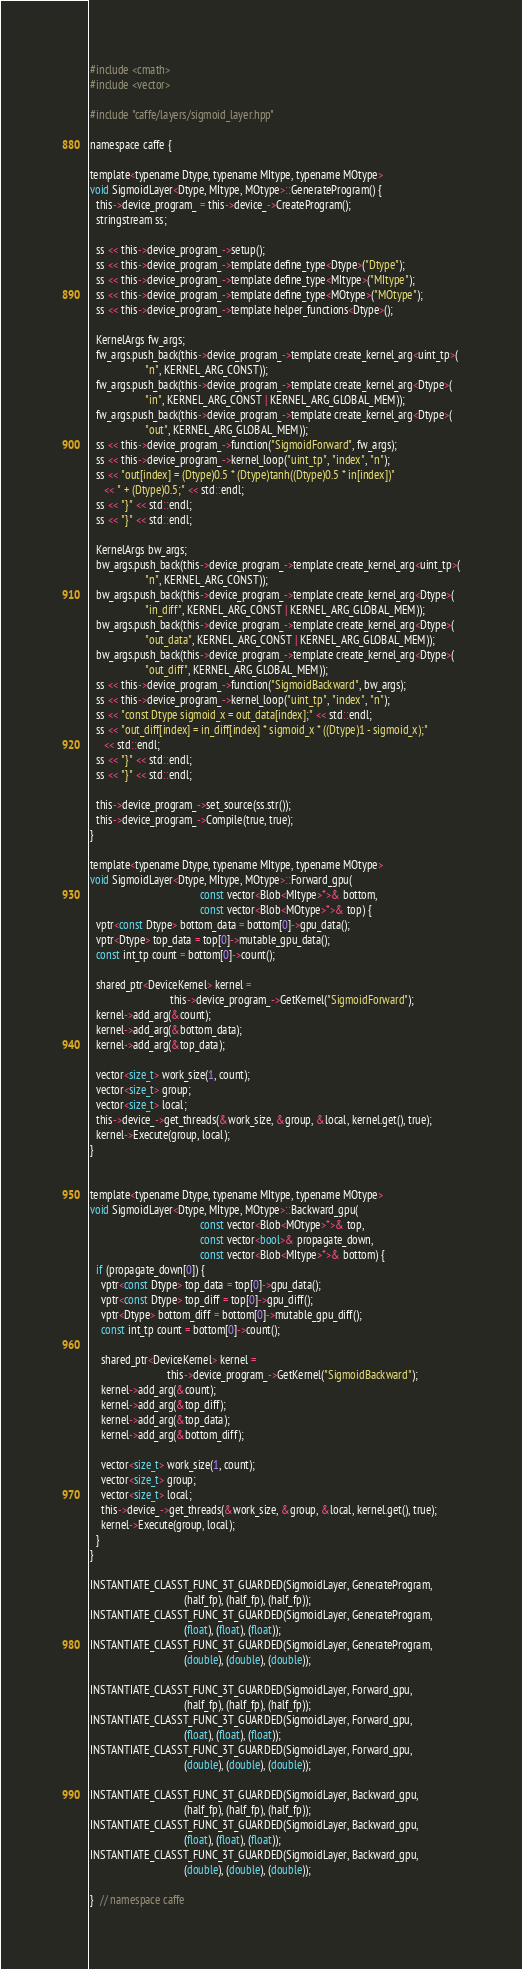<code> <loc_0><loc_0><loc_500><loc_500><_Cuda_>#include <cmath>
#include <vector>

#include "caffe/layers/sigmoid_layer.hpp"

namespace caffe {

template<typename Dtype, typename MItype, typename MOtype>
void SigmoidLayer<Dtype, MItype, MOtype>::GenerateProgram() {
  this->device_program_ = this->device_->CreateProgram();
  stringstream ss;

  ss << this->device_program_->setup();
  ss << this->device_program_->template define_type<Dtype>("Dtype");
  ss << this->device_program_->template define_type<MItype>("MItype");
  ss << this->device_program_->template define_type<MOtype>("MOtype");
  ss << this->device_program_->template helper_functions<Dtype>();

  KernelArgs fw_args;
  fw_args.push_back(this->device_program_->template create_kernel_arg<uint_tp>(
                    "n", KERNEL_ARG_CONST));
  fw_args.push_back(this->device_program_->template create_kernel_arg<Dtype>(
                    "in", KERNEL_ARG_CONST | KERNEL_ARG_GLOBAL_MEM));
  fw_args.push_back(this->device_program_->template create_kernel_arg<Dtype>(
                    "out", KERNEL_ARG_GLOBAL_MEM));
  ss << this->device_program_->function("SigmoidForward", fw_args);
  ss << this->device_program_->kernel_loop("uint_tp", "index", "n");
  ss << "out[index] = (Dtype)0.5 * (Dtype)tanh((Dtype)0.5 * in[index])"
     << " + (Dtype)0.5;" << std::endl;
  ss << "}" << std::endl;
  ss << "}" << std::endl;

  KernelArgs bw_args;
  bw_args.push_back(this->device_program_->template create_kernel_arg<uint_tp>(
                    "n", KERNEL_ARG_CONST));
  bw_args.push_back(this->device_program_->template create_kernel_arg<Dtype>(
                    "in_diff", KERNEL_ARG_CONST | KERNEL_ARG_GLOBAL_MEM));
  bw_args.push_back(this->device_program_->template create_kernel_arg<Dtype>(
                    "out_data", KERNEL_ARG_CONST | KERNEL_ARG_GLOBAL_MEM));
  bw_args.push_back(this->device_program_->template create_kernel_arg<Dtype>(
                    "out_diff", KERNEL_ARG_GLOBAL_MEM));
  ss << this->device_program_->function("SigmoidBackward", bw_args);
  ss << this->device_program_->kernel_loop("uint_tp", "index", "n");
  ss << "const Dtype sigmoid_x = out_data[index];" << std::endl;
  ss << "out_diff[index] = in_diff[index] * sigmoid_x * ((Dtype)1 - sigmoid_x);"
     << std::endl;
  ss << "}" << std::endl;
  ss << "}" << std::endl;

  this->device_program_->set_source(ss.str());
  this->device_program_->Compile(true, true);
}

template<typename Dtype, typename MItype, typename MOtype>
void SigmoidLayer<Dtype, MItype, MOtype>::Forward_gpu(
                                        const vector<Blob<MItype>*>& bottom,
                                        const vector<Blob<MOtype>*>& top) {
  vptr<const Dtype> bottom_data = bottom[0]->gpu_data();
  vptr<Dtype> top_data = top[0]->mutable_gpu_data();
  const int_tp count = bottom[0]->count();

  shared_ptr<DeviceKernel> kernel =
                             this->device_program_->GetKernel("SigmoidForward");
  kernel->add_arg(&count);
  kernel->add_arg(&bottom_data);
  kernel->add_arg(&top_data);

  vector<size_t> work_size(1, count);
  vector<size_t> group;
  vector<size_t> local;
  this->device_->get_threads(&work_size, &group, &local, kernel.get(), true);
  kernel->Execute(group, local);
}


template<typename Dtype, typename MItype, typename MOtype>
void SigmoidLayer<Dtype, MItype, MOtype>::Backward_gpu(
                                        const vector<Blob<MOtype>*>& top,
                                        const vector<bool>& propagate_down,
                                        const vector<Blob<MItype>*>& bottom) {
  if (propagate_down[0]) {
    vptr<const Dtype> top_data = top[0]->gpu_data();
    vptr<const Dtype> top_diff = top[0]->gpu_diff();
    vptr<Dtype> bottom_diff = bottom[0]->mutable_gpu_diff();
    const int_tp count = bottom[0]->count();

    shared_ptr<DeviceKernel> kernel =
                            this->device_program_->GetKernel("SigmoidBackward");
    kernel->add_arg(&count);
    kernel->add_arg(&top_diff);
    kernel->add_arg(&top_data);
    kernel->add_arg(&bottom_diff);

    vector<size_t> work_size(1, count);
    vector<size_t> group;
    vector<size_t> local;
    this->device_->get_threads(&work_size, &group, &local, kernel.get(), true);
    kernel->Execute(group, local);
  }
}

INSTANTIATE_CLASST_FUNC_3T_GUARDED(SigmoidLayer, GenerateProgram,
                                  (half_fp), (half_fp), (half_fp));
INSTANTIATE_CLASST_FUNC_3T_GUARDED(SigmoidLayer, GenerateProgram,
                                  (float), (float), (float));
INSTANTIATE_CLASST_FUNC_3T_GUARDED(SigmoidLayer, GenerateProgram,
                                  (double), (double), (double));

INSTANTIATE_CLASST_FUNC_3T_GUARDED(SigmoidLayer, Forward_gpu,
                                  (half_fp), (half_fp), (half_fp));
INSTANTIATE_CLASST_FUNC_3T_GUARDED(SigmoidLayer, Forward_gpu,
                                  (float), (float), (float));
INSTANTIATE_CLASST_FUNC_3T_GUARDED(SigmoidLayer, Forward_gpu,
                                  (double), (double), (double));

INSTANTIATE_CLASST_FUNC_3T_GUARDED(SigmoidLayer, Backward_gpu,
                                  (half_fp), (half_fp), (half_fp));
INSTANTIATE_CLASST_FUNC_3T_GUARDED(SigmoidLayer, Backward_gpu,
                                  (float), (float), (float));
INSTANTIATE_CLASST_FUNC_3T_GUARDED(SigmoidLayer, Backward_gpu,
                                  (double), (double), (double));

}  // namespace caffe
</code> 